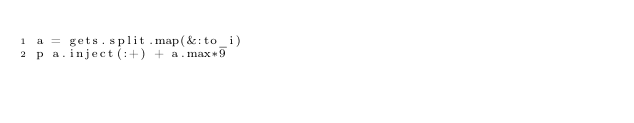<code> <loc_0><loc_0><loc_500><loc_500><_Ruby_>a = gets.split.map(&:to_i)
p a.inject(:+) + a.max*9</code> 